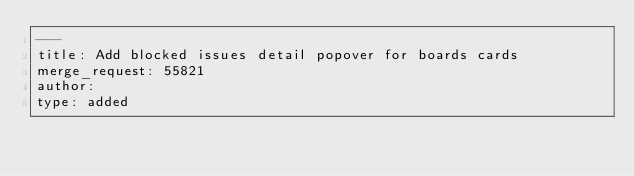<code> <loc_0><loc_0><loc_500><loc_500><_YAML_>---
title: Add blocked issues detail popover for boards cards
merge_request: 55821
author:
type: added
</code> 